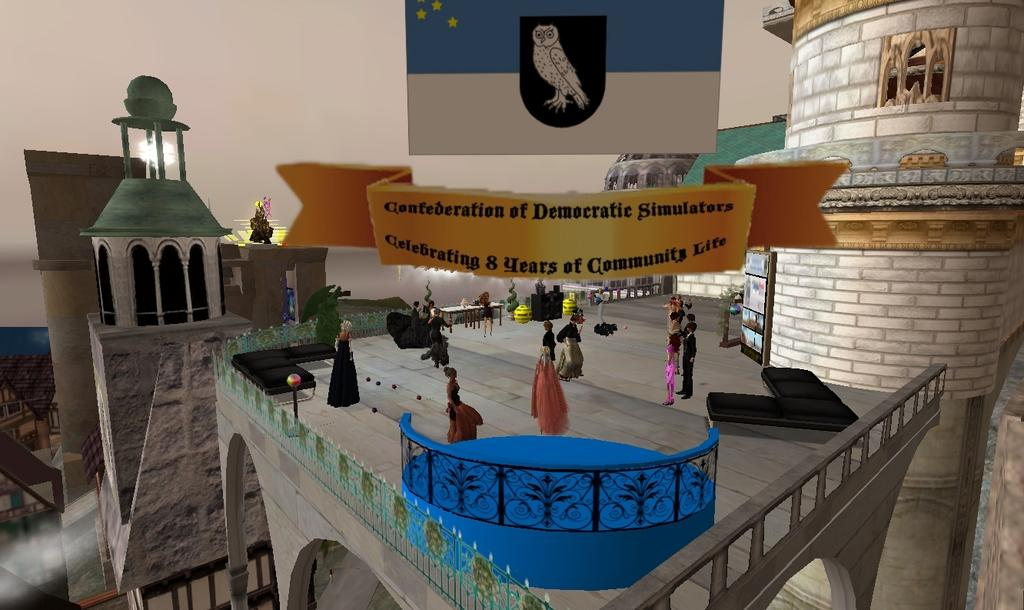What style is the image drawn in? The image is a cartoon. What type of structures can be seen in the image? There are buildings in the image. Are there any human figures in the image? Yes, there are people standing in the image. What symbol is present in the image? There is a flag in the image. What type of plants are growing in the image? There are no plants visible in the image. What is the title of the cartoon in the image? The provided facts do not mention a title for the cartoon. 